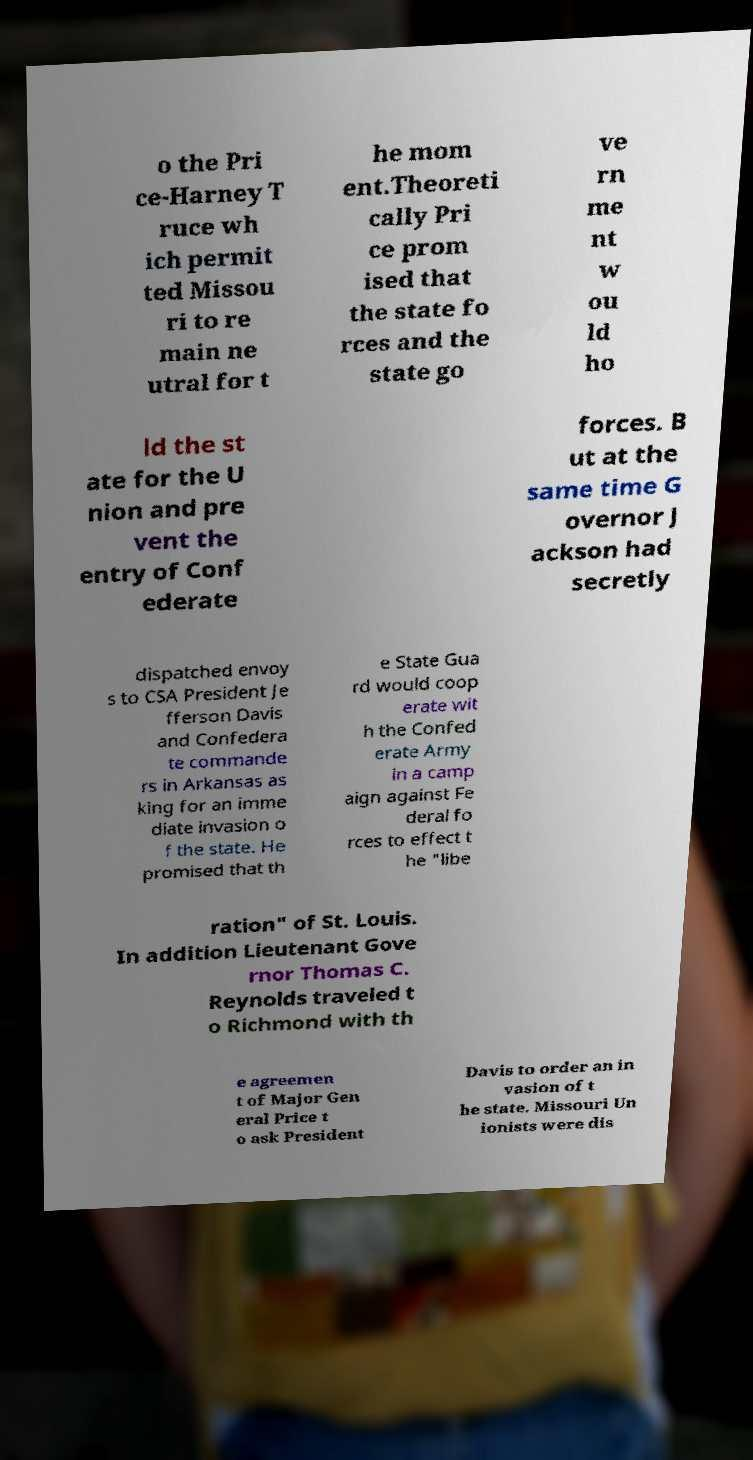What messages or text are displayed in this image? I need them in a readable, typed format. o the Pri ce-Harney T ruce wh ich permit ted Missou ri to re main ne utral for t he mom ent.Theoreti cally Pri ce prom ised that the state fo rces and the state go ve rn me nt w ou ld ho ld the st ate for the U nion and pre vent the entry of Conf ederate forces. B ut at the same time G overnor J ackson had secretly dispatched envoy s to CSA President Je fferson Davis and Confedera te commande rs in Arkansas as king for an imme diate invasion o f the state. He promised that th e State Gua rd would coop erate wit h the Confed erate Army in a camp aign against Fe deral fo rces to effect t he "libe ration" of St. Louis. In addition Lieutenant Gove rnor Thomas C. Reynolds traveled t o Richmond with th e agreemen t of Major Gen eral Price t o ask President Davis to order an in vasion of t he state. Missouri Un ionists were dis 